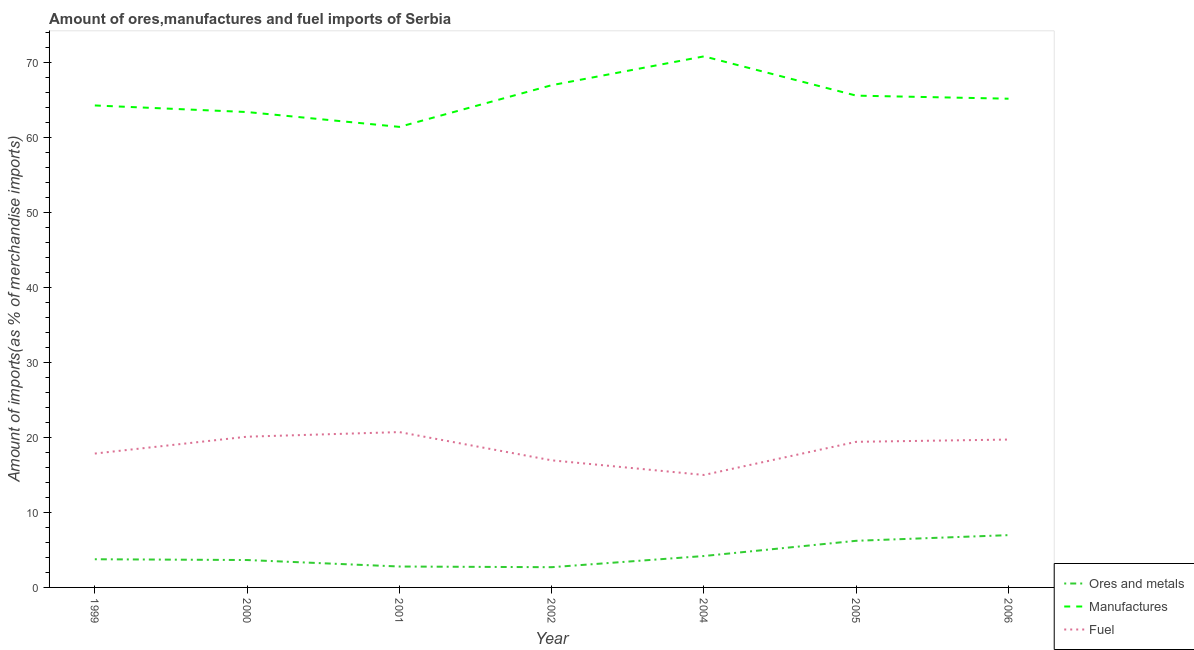What is the percentage of fuel imports in 2002?
Provide a succinct answer. 16.93. Across all years, what is the maximum percentage of ores and metals imports?
Your answer should be very brief. 6.97. Across all years, what is the minimum percentage of fuel imports?
Keep it short and to the point. 14.98. What is the total percentage of fuel imports in the graph?
Your response must be concise. 129.63. What is the difference between the percentage of ores and metals imports in 2002 and that in 2005?
Your answer should be very brief. -3.52. What is the difference between the percentage of manufactures imports in 2005 and the percentage of ores and metals imports in 2000?
Offer a very short reply. 61.87. What is the average percentage of manufactures imports per year?
Provide a short and direct response. 65.32. In the year 2000, what is the difference between the percentage of manufactures imports and percentage of ores and metals imports?
Keep it short and to the point. 59.69. In how many years, is the percentage of manufactures imports greater than 48 %?
Your response must be concise. 7. What is the ratio of the percentage of manufactures imports in 2000 to that in 2001?
Make the answer very short. 1.03. What is the difference between the highest and the second highest percentage of ores and metals imports?
Make the answer very short. 0.75. What is the difference between the highest and the lowest percentage of fuel imports?
Offer a terse response. 5.71. Is it the case that in every year, the sum of the percentage of ores and metals imports and percentage of manufactures imports is greater than the percentage of fuel imports?
Your response must be concise. Yes. Is the percentage of fuel imports strictly greater than the percentage of manufactures imports over the years?
Offer a terse response. No. Is the percentage of fuel imports strictly less than the percentage of ores and metals imports over the years?
Offer a very short reply. No. What is the difference between two consecutive major ticks on the Y-axis?
Your answer should be compact. 10. Does the graph contain any zero values?
Ensure brevity in your answer.  No. Does the graph contain grids?
Offer a terse response. No. Where does the legend appear in the graph?
Your answer should be very brief. Bottom right. How many legend labels are there?
Your answer should be very brief. 3. What is the title of the graph?
Make the answer very short. Amount of ores,manufactures and fuel imports of Serbia. What is the label or title of the Y-axis?
Your answer should be compact. Amount of imports(as % of merchandise imports). What is the Amount of imports(as % of merchandise imports) of Ores and metals in 1999?
Ensure brevity in your answer.  3.75. What is the Amount of imports(as % of merchandise imports) of Manufactures in 1999?
Your answer should be very brief. 64.21. What is the Amount of imports(as % of merchandise imports) of Fuel in 1999?
Give a very brief answer. 17.84. What is the Amount of imports(as % of merchandise imports) of Ores and metals in 2000?
Keep it short and to the point. 3.65. What is the Amount of imports(as % of merchandise imports) of Manufactures in 2000?
Your response must be concise. 63.34. What is the Amount of imports(as % of merchandise imports) in Fuel in 2000?
Your response must be concise. 20.08. What is the Amount of imports(as % of merchandise imports) in Ores and metals in 2001?
Your response must be concise. 2.79. What is the Amount of imports(as % of merchandise imports) in Manufactures in 2001?
Your response must be concise. 61.36. What is the Amount of imports(as % of merchandise imports) of Fuel in 2001?
Give a very brief answer. 20.7. What is the Amount of imports(as % of merchandise imports) in Ores and metals in 2002?
Your answer should be very brief. 2.7. What is the Amount of imports(as % of merchandise imports) of Manufactures in 2002?
Give a very brief answer. 66.91. What is the Amount of imports(as % of merchandise imports) in Fuel in 2002?
Offer a terse response. 16.93. What is the Amount of imports(as % of merchandise imports) of Ores and metals in 2004?
Offer a terse response. 4.18. What is the Amount of imports(as % of merchandise imports) in Manufactures in 2004?
Give a very brief answer. 70.75. What is the Amount of imports(as % of merchandise imports) of Fuel in 2004?
Your answer should be very brief. 14.98. What is the Amount of imports(as % of merchandise imports) of Ores and metals in 2005?
Give a very brief answer. 6.21. What is the Amount of imports(as % of merchandise imports) of Manufactures in 2005?
Make the answer very short. 65.52. What is the Amount of imports(as % of merchandise imports) in Fuel in 2005?
Your answer should be compact. 19.4. What is the Amount of imports(as % of merchandise imports) in Ores and metals in 2006?
Give a very brief answer. 6.97. What is the Amount of imports(as % of merchandise imports) of Manufactures in 2006?
Make the answer very short. 65.11. What is the Amount of imports(as % of merchandise imports) of Fuel in 2006?
Your answer should be compact. 19.7. Across all years, what is the maximum Amount of imports(as % of merchandise imports) of Ores and metals?
Offer a terse response. 6.97. Across all years, what is the maximum Amount of imports(as % of merchandise imports) of Manufactures?
Give a very brief answer. 70.75. Across all years, what is the maximum Amount of imports(as % of merchandise imports) in Fuel?
Give a very brief answer. 20.7. Across all years, what is the minimum Amount of imports(as % of merchandise imports) of Ores and metals?
Give a very brief answer. 2.7. Across all years, what is the minimum Amount of imports(as % of merchandise imports) of Manufactures?
Provide a short and direct response. 61.36. Across all years, what is the minimum Amount of imports(as % of merchandise imports) in Fuel?
Your response must be concise. 14.98. What is the total Amount of imports(as % of merchandise imports) of Ores and metals in the graph?
Make the answer very short. 30.25. What is the total Amount of imports(as % of merchandise imports) in Manufactures in the graph?
Provide a short and direct response. 457.21. What is the total Amount of imports(as % of merchandise imports) in Fuel in the graph?
Keep it short and to the point. 129.63. What is the difference between the Amount of imports(as % of merchandise imports) in Ores and metals in 1999 and that in 2000?
Your answer should be very brief. 0.1. What is the difference between the Amount of imports(as % of merchandise imports) in Manufactures in 1999 and that in 2000?
Provide a short and direct response. 0.88. What is the difference between the Amount of imports(as % of merchandise imports) of Fuel in 1999 and that in 2000?
Provide a short and direct response. -2.25. What is the difference between the Amount of imports(as % of merchandise imports) in Ores and metals in 1999 and that in 2001?
Ensure brevity in your answer.  0.97. What is the difference between the Amount of imports(as % of merchandise imports) of Manufactures in 1999 and that in 2001?
Provide a short and direct response. 2.85. What is the difference between the Amount of imports(as % of merchandise imports) of Fuel in 1999 and that in 2001?
Give a very brief answer. -2.86. What is the difference between the Amount of imports(as % of merchandise imports) of Ores and metals in 1999 and that in 2002?
Keep it short and to the point. 1.06. What is the difference between the Amount of imports(as % of merchandise imports) in Manufactures in 1999 and that in 2002?
Your answer should be compact. -2.7. What is the difference between the Amount of imports(as % of merchandise imports) in Fuel in 1999 and that in 2002?
Offer a very short reply. 0.9. What is the difference between the Amount of imports(as % of merchandise imports) of Ores and metals in 1999 and that in 2004?
Your response must be concise. -0.43. What is the difference between the Amount of imports(as % of merchandise imports) in Manufactures in 1999 and that in 2004?
Make the answer very short. -6.54. What is the difference between the Amount of imports(as % of merchandise imports) in Fuel in 1999 and that in 2004?
Make the answer very short. 2.85. What is the difference between the Amount of imports(as % of merchandise imports) in Ores and metals in 1999 and that in 2005?
Your answer should be compact. -2.46. What is the difference between the Amount of imports(as % of merchandise imports) in Manufactures in 1999 and that in 2005?
Provide a succinct answer. -1.31. What is the difference between the Amount of imports(as % of merchandise imports) of Fuel in 1999 and that in 2005?
Provide a short and direct response. -1.56. What is the difference between the Amount of imports(as % of merchandise imports) in Ores and metals in 1999 and that in 2006?
Give a very brief answer. -3.21. What is the difference between the Amount of imports(as % of merchandise imports) of Manufactures in 1999 and that in 2006?
Ensure brevity in your answer.  -0.9. What is the difference between the Amount of imports(as % of merchandise imports) in Fuel in 1999 and that in 2006?
Your response must be concise. -1.86. What is the difference between the Amount of imports(as % of merchandise imports) of Ores and metals in 2000 and that in 2001?
Your answer should be compact. 0.86. What is the difference between the Amount of imports(as % of merchandise imports) of Manufactures in 2000 and that in 2001?
Offer a terse response. 1.98. What is the difference between the Amount of imports(as % of merchandise imports) of Fuel in 2000 and that in 2001?
Offer a terse response. -0.61. What is the difference between the Amount of imports(as % of merchandise imports) in Ores and metals in 2000 and that in 2002?
Provide a short and direct response. 0.95. What is the difference between the Amount of imports(as % of merchandise imports) of Manufactures in 2000 and that in 2002?
Your response must be concise. -3.58. What is the difference between the Amount of imports(as % of merchandise imports) in Fuel in 2000 and that in 2002?
Give a very brief answer. 3.15. What is the difference between the Amount of imports(as % of merchandise imports) in Ores and metals in 2000 and that in 2004?
Ensure brevity in your answer.  -0.53. What is the difference between the Amount of imports(as % of merchandise imports) of Manufactures in 2000 and that in 2004?
Keep it short and to the point. -7.42. What is the difference between the Amount of imports(as % of merchandise imports) of Fuel in 2000 and that in 2004?
Your response must be concise. 5.1. What is the difference between the Amount of imports(as % of merchandise imports) of Ores and metals in 2000 and that in 2005?
Your response must be concise. -2.56. What is the difference between the Amount of imports(as % of merchandise imports) in Manufactures in 2000 and that in 2005?
Your answer should be very brief. -2.19. What is the difference between the Amount of imports(as % of merchandise imports) of Fuel in 2000 and that in 2005?
Offer a terse response. 0.68. What is the difference between the Amount of imports(as % of merchandise imports) of Ores and metals in 2000 and that in 2006?
Your answer should be very brief. -3.32. What is the difference between the Amount of imports(as % of merchandise imports) of Manufactures in 2000 and that in 2006?
Provide a succinct answer. -1.78. What is the difference between the Amount of imports(as % of merchandise imports) of Fuel in 2000 and that in 2006?
Offer a terse response. 0.38. What is the difference between the Amount of imports(as % of merchandise imports) in Ores and metals in 2001 and that in 2002?
Your response must be concise. 0.09. What is the difference between the Amount of imports(as % of merchandise imports) of Manufactures in 2001 and that in 2002?
Your response must be concise. -5.55. What is the difference between the Amount of imports(as % of merchandise imports) in Fuel in 2001 and that in 2002?
Offer a terse response. 3.76. What is the difference between the Amount of imports(as % of merchandise imports) of Ores and metals in 2001 and that in 2004?
Provide a short and direct response. -1.4. What is the difference between the Amount of imports(as % of merchandise imports) in Manufactures in 2001 and that in 2004?
Keep it short and to the point. -9.4. What is the difference between the Amount of imports(as % of merchandise imports) of Fuel in 2001 and that in 2004?
Make the answer very short. 5.71. What is the difference between the Amount of imports(as % of merchandise imports) of Ores and metals in 2001 and that in 2005?
Your response must be concise. -3.43. What is the difference between the Amount of imports(as % of merchandise imports) of Manufactures in 2001 and that in 2005?
Your answer should be compact. -4.16. What is the difference between the Amount of imports(as % of merchandise imports) in Fuel in 2001 and that in 2005?
Your answer should be compact. 1.3. What is the difference between the Amount of imports(as % of merchandise imports) in Ores and metals in 2001 and that in 2006?
Give a very brief answer. -4.18. What is the difference between the Amount of imports(as % of merchandise imports) of Manufactures in 2001 and that in 2006?
Your response must be concise. -3.75. What is the difference between the Amount of imports(as % of merchandise imports) in Fuel in 2001 and that in 2006?
Make the answer very short. 1. What is the difference between the Amount of imports(as % of merchandise imports) in Ores and metals in 2002 and that in 2004?
Your answer should be very brief. -1.49. What is the difference between the Amount of imports(as % of merchandise imports) in Manufactures in 2002 and that in 2004?
Your answer should be compact. -3.84. What is the difference between the Amount of imports(as % of merchandise imports) in Fuel in 2002 and that in 2004?
Ensure brevity in your answer.  1.95. What is the difference between the Amount of imports(as % of merchandise imports) in Ores and metals in 2002 and that in 2005?
Provide a short and direct response. -3.52. What is the difference between the Amount of imports(as % of merchandise imports) in Manufactures in 2002 and that in 2005?
Offer a very short reply. 1.39. What is the difference between the Amount of imports(as % of merchandise imports) of Fuel in 2002 and that in 2005?
Offer a terse response. -2.47. What is the difference between the Amount of imports(as % of merchandise imports) in Ores and metals in 2002 and that in 2006?
Your response must be concise. -4.27. What is the difference between the Amount of imports(as % of merchandise imports) in Manufactures in 2002 and that in 2006?
Give a very brief answer. 1.8. What is the difference between the Amount of imports(as % of merchandise imports) of Fuel in 2002 and that in 2006?
Provide a short and direct response. -2.77. What is the difference between the Amount of imports(as % of merchandise imports) of Ores and metals in 2004 and that in 2005?
Provide a succinct answer. -2.03. What is the difference between the Amount of imports(as % of merchandise imports) of Manufactures in 2004 and that in 2005?
Give a very brief answer. 5.23. What is the difference between the Amount of imports(as % of merchandise imports) of Fuel in 2004 and that in 2005?
Ensure brevity in your answer.  -4.42. What is the difference between the Amount of imports(as % of merchandise imports) of Ores and metals in 2004 and that in 2006?
Your answer should be compact. -2.78. What is the difference between the Amount of imports(as % of merchandise imports) of Manufactures in 2004 and that in 2006?
Provide a short and direct response. 5.64. What is the difference between the Amount of imports(as % of merchandise imports) in Fuel in 2004 and that in 2006?
Keep it short and to the point. -4.72. What is the difference between the Amount of imports(as % of merchandise imports) in Ores and metals in 2005 and that in 2006?
Your answer should be very brief. -0.75. What is the difference between the Amount of imports(as % of merchandise imports) in Manufactures in 2005 and that in 2006?
Make the answer very short. 0.41. What is the difference between the Amount of imports(as % of merchandise imports) of Fuel in 2005 and that in 2006?
Give a very brief answer. -0.3. What is the difference between the Amount of imports(as % of merchandise imports) of Ores and metals in 1999 and the Amount of imports(as % of merchandise imports) of Manufactures in 2000?
Your answer should be compact. -59.58. What is the difference between the Amount of imports(as % of merchandise imports) of Ores and metals in 1999 and the Amount of imports(as % of merchandise imports) of Fuel in 2000?
Ensure brevity in your answer.  -16.33. What is the difference between the Amount of imports(as % of merchandise imports) in Manufactures in 1999 and the Amount of imports(as % of merchandise imports) in Fuel in 2000?
Your response must be concise. 44.13. What is the difference between the Amount of imports(as % of merchandise imports) of Ores and metals in 1999 and the Amount of imports(as % of merchandise imports) of Manufactures in 2001?
Offer a very short reply. -57.6. What is the difference between the Amount of imports(as % of merchandise imports) in Ores and metals in 1999 and the Amount of imports(as % of merchandise imports) in Fuel in 2001?
Give a very brief answer. -16.94. What is the difference between the Amount of imports(as % of merchandise imports) in Manufactures in 1999 and the Amount of imports(as % of merchandise imports) in Fuel in 2001?
Make the answer very short. 43.52. What is the difference between the Amount of imports(as % of merchandise imports) of Ores and metals in 1999 and the Amount of imports(as % of merchandise imports) of Manufactures in 2002?
Make the answer very short. -63.16. What is the difference between the Amount of imports(as % of merchandise imports) of Ores and metals in 1999 and the Amount of imports(as % of merchandise imports) of Fuel in 2002?
Your answer should be compact. -13.18. What is the difference between the Amount of imports(as % of merchandise imports) of Manufactures in 1999 and the Amount of imports(as % of merchandise imports) of Fuel in 2002?
Make the answer very short. 47.28. What is the difference between the Amount of imports(as % of merchandise imports) of Ores and metals in 1999 and the Amount of imports(as % of merchandise imports) of Manufactures in 2004?
Ensure brevity in your answer.  -67. What is the difference between the Amount of imports(as % of merchandise imports) in Ores and metals in 1999 and the Amount of imports(as % of merchandise imports) in Fuel in 2004?
Your response must be concise. -11.23. What is the difference between the Amount of imports(as % of merchandise imports) of Manufactures in 1999 and the Amount of imports(as % of merchandise imports) of Fuel in 2004?
Provide a short and direct response. 49.23. What is the difference between the Amount of imports(as % of merchandise imports) in Ores and metals in 1999 and the Amount of imports(as % of merchandise imports) in Manufactures in 2005?
Provide a succinct answer. -61.77. What is the difference between the Amount of imports(as % of merchandise imports) of Ores and metals in 1999 and the Amount of imports(as % of merchandise imports) of Fuel in 2005?
Ensure brevity in your answer.  -15.65. What is the difference between the Amount of imports(as % of merchandise imports) in Manufactures in 1999 and the Amount of imports(as % of merchandise imports) in Fuel in 2005?
Your response must be concise. 44.81. What is the difference between the Amount of imports(as % of merchandise imports) of Ores and metals in 1999 and the Amount of imports(as % of merchandise imports) of Manufactures in 2006?
Your response must be concise. -61.36. What is the difference between the Amount of imports(as % of merchandise imports) in Ores and metals in 1999 and the Amount of imports(as % of merchandise imports) in Fuel in 2006?
Provide a succinct answer. -15.95. What is the difference between the Amount of imports(as % of merchandise imports) of Manufactures in 1999 and the Amount of imports(as % of merchandise imports) of Fuel in 2006?
Your response must be concise. 44.51. What is the difference between the Amount of imports(as % of merchandise imports) of Ores and metals in 2000 and the Amount of imports(as % of merchandise imports) of Manufactures in 2001?
Provide a succinct answer. -57.71. What is the difference between the Amount of imports(as % of merchandise imports) in Ores and metals in 2000 and the Amount of imports(as % of merchandise imports) in Fuel in 2001?
Offer a very short reply. -17.05. What is the difference between the Amount of imports(as % of merchandise imports) in Manufactures in 2000 and the Amount of imports(as % of merchandise imports) in Fuel in 2001?
Your response must be concise. 42.64. What is the difference between the Amount of imports(as % of merchandise imports) in Ores and metals in 2000 and the Amount of imports(as % of merchandise imports) in Manufactures in 2002?
Give a very brief answer. -63.26. What is the difference between the Amount of imports(as % of merchandise imports) of Ores and metals in 2000 and the Amount of imports(as % of merchandise imports) of Fuel in 2002?
Your answer should be compact. -13.28. What is the difference between the Amount of imports(as % of merchandise imports) in Manufactures in 2000 and the Amount of imports(as % of merchandise imports) in Fuel in 2002?
Offer a terse response. 46.4. What is the difference between the Amount of imports(as % of merchandise imports) in Ores and metals in 2000 and the Amount of imports(as % of merchandise imports) in Manufactures in 2004?
Your answer should be compact. -67.1. What is the difference between the Amount of imports(as % of merchandise imports) in Ores and metals in 2000 and the Amount of imports(as % of merchandise imports) in Fuel in 2004?
Offer a terse response. -11.33. What is the difference between the Amount of imports(as % of merchandise imports) in Manufactures in 2000 and the Amount of imports(as % of merchandise imports) in Fuel in 2004?
Give a very brief answer. 48.35. What is the difference between the Amount of imports(as % of merchandise imports) of Ores and metals in 2000 and the Amount of imports(as % of merchandise imports) of Manufactures in 2005?
Offer a very short reply. -61.87. What is the difference between the Amount of imports(as % of merchandise imports) in Ores and metals in 2000 and the Amount of imports(as % of merchandise imports) in Fuel in 2005?
Your answer should be compact. -15.75. What is the difference between the Amount of imports(as % of merchandise imports) of Manufactures in 2000 and the Amount of imports(as % of merchandise imports) of Fuel in 2005?
Give a very brief answer. 43.94. What is the difference between the Amount of imports(as % of merchandise imports) in Ores and metals in 2000 and the Amount of imports(as % of merchandise imports) in Manufactures in 2006?
Offer a terse response. -61.46. What is the difference between the Amount of imports(as % of merchandise imports) in Ores and metals in 2000 and the Amount of imports(as % of merchandise imports) in Fuel in 2006?
Make the answer very short. -16.05. What is the difference between the Amount of imports(as % of merchandise imports) of Manufactures in 2000 and the Amount of imports(as % of merchandise imports) of Fuel in 2006?
Keep it short and to the point. 43.64. What is the difference between the Amount of imports(as % of merchandise imports) of Ores and metals in 2001 and the Amount of imports(as % of merchandise imports) of Manufactures in 2002?
Your response must be concise. -64.13. What is the difference between the Amount of imports(as % of merchandise imports) of Ores and metals in 2001 and the Amount of imports(as % of merchandise imports) of Fuel in 2002?
Keep it short and to the point. -14.15. What is the difference between the Amount of imports(as % of merchandise imports) in Manufactures in 2001 and the Amount of imports(as % of merchandise imports) in Fuel in 2002?
Your answer should be compact. 44.42. What is the difference between the Amount of imports(as % of merchandise imports) in Ores and metals in 2001 and the Amount of imports(as % of merchandise imports) in Manufactures in 2004?
Your answer should be compact. -67.97. What is the difference between the Amount of imports(as % of merchandise imports) in Ores and metals in 2001 and the Amount of imports(as % of merchandise imports) in Fuel in 2004?
Make the answer very short. -12.2. What is the difference between the Amount of imports(as % of merchandise imports) in Manufactures in 2001 and the Amount of imports(as % of merchandise imports) in Fuel in 2004?
Your response must be concise. 46.37. What is the difference between the Amount of imports(as % of merchandise imports) of Ores and metals in 2001 and the Amount of imports(as % of merchandise imports) of Manufactures in 2005?
Ensure brevity in your answer.  -62.74. What is the difference between the Amount of imports(as % of merchandise imports) in Ores and metals in 2001 and the Amount of imports(as % of merchandise imports) in Fuel in 2005?
Ensure brevity in your answer.  -16.61. What is the difference between the Amount of imports(as % of merchandise imports) of Manufactures in 2001 and the Amount of imports(as % of merchandise imports) of Fuel in 2005?
Provide a short and direct response. 41.96. What is the difference between the Amount of imports(as % of merchandise imports) of Ores and metals in 2001 and the Amount of imports(as % of merchandise imports) of Manufactures in 2006?
Your response must be concise. -62.33. What is the difference between the Amount of imports(as % of merchandise imports) in Ores and metals in 2001 and the Amount of imports(as % of merchandise imports) in Fuel in 2006?
Your answer should be very brief. -16.91. What is the difference between the Amount of imports(as % of merchandise imports) in Manufactures in 2001 and the Amount of imports(as % of merchandise imports) in Fuel in 2006?
Your response must be concise. 41.66. What is the difference between the Amount of imports(as % of merchandise imports) of Ores and metals in 2002 and the Amount of imports(as % of merchandise imports) of Manufactures in 2004?
Provide a succinct answer. -68.06. What is the difference between the Amount of imports(as % of merchandise imports) of Ores and metals in 2002 and the Amount of imports(as % of merchandise imports) of Fuel in 2004?
Offer a very short reply. -12.29. What is the difference between the Amount of imports(as % of merchandise imports) of Manufactures in 2002 and the Amount of imports(as % of merchandise imports) of Fuel in 2004?
Provide a short and direct response. 51.93. What is the difference between the Amount of imports(as % of merchandise imports) in Ores and metals in 2002 and the Amount of imports(as % of merchandise imports) in Manufactures in 2005?
Your answer should be very brief. -62.83. What is the difference between the Amount of imports(as % of merchandise imports) of Ores and metals in 2002 and the Amount of imports(as % of merchandise imports) of Fuel in 2005?
Provide a short and direct response. -16.7. What is the difference between the Amount of imports(as % of merchandise imports) of Manufactures in 2002 and the Amount of imports(as % of merchandise imports) of Fuel in 2005?
Ensure brevity in your answer.  47.51. What is the difference between the Amount of imports(as % of merchandise imports) of Ores and metals in 2002 and the Amount of imports(as % of merchandise imports) of Manufactures in 2006?
Give a very brief answer. -62.42. What is the difference between the Amount of imports(as % of merchandise imports) of Ores and metals in 2002 and the Amount of imports(as % of merchandise imports) of Fuel in 2006?
Your response must be concise. -17. What is the difference between the Amount of imports(as % of merchandise imports) of Manufactures in 2002 and the Amount of imports(as % of merchandise imports) of Fuel in 2006?
Offer a terse response. 47.21. What is the difference between the Amount of imports(as % of merchandise imports) of Ores and metals in 2004 and the Amount of imports(as % of merchandise imports) of Manufactures in 2005?
Offer a very short reply. -61.34. What is the difference between the Amount of imports(as % of merchandise imports) of Ores and metals in 2004 and the Amount of imports(as % of merchandise imports) of Fuel in 2005?
Provide a succinct answer. -15.22. What is the difference between the Amount of imports(as % of merchandise imports) of Manufactures in 2004 and the Amount of imports(as % of merchandise imports) of Fuel in 2005?
Provide a succinct answer. 51.35. What is the difference between the Amount of imports(as % of merchandise imports) of Ores and metals in 2004 and the Amount of imports(as % of merchandise imports) of Manufactures in 2006?
Your answer should be compact. -60.93. What is the difference between the Amount of imports(as % of merchandise imports) in Ores and metals in 2004 and the Amount of imports(as % of merchandise imports) in Fuel in 2006?
Your answer should be compact. -15.52. What is the difference between the Amount of imports(as % of merchandise imports) of Manufactures in 2004 and the Amount of imports(as % of merchandise imports) of Fuel in 2006?
Offer a very short reply. 51.05. What is the difference between the Amount of imports(as % of merchandise imports) of Ores and metals in 2005 and the Amount of imports(as % of merchandise imports) of Manufactures in 2006?
Your answer should be compact. -58.9. What is the difference between the Amount of imports(as % of merchandise imports) in Ores and metals in 2005 and the Amount of imports(as % of merchandise imports) in Fuel in 2006?
Ensure brevity in your answer.  -13.49. What is the difference between the Amount of imports(as % of merchandise imports) in Manufactures in 2005 and the Amount of imports(as % of merchandise imports) in Fuel in 2006?
Offer a terse response. 45.82. What is the average Amount of imports(as % of merchandise imports) of Ores and metals per year?
Ensure brevity in your answer.  4.32. What is the average Amount of imports(as % of merchandise imports) in Manufactures per year?
Provide a succinct answer. 65.32. What is the average Amount of imports(as % of merchandise imports) in Fuel per year?
Provide a short and direct response. 18.52. In the year 1999, what is the difference between the Amount of imports(as % of merchandise imports) of Ores and metals and Amount of imports(as % of merchandise imports) of Manufactures?
Offer a terse response. -60.46. In the year 1999, what is the difference between the Amount of imports(as % of merchandise imports) in Ores and metals and Amount of imports(as % of merchandise imports) in Fuel?
Your answer should be compact. -14.08. In the year 1999, what is the difference between the Amount of imports(as % of merchandise imports) of Manufactures and Amount of imports(as % of merchandise imports) of Fuel?
Your answer should be compact. 46.38. In the year 2000, what is the difference between the Amount of imports(as % of merchandise imports) of Ores and metals and Amount of imports(as % of merchandise imports) of Manufactures?
Your answer should be very brief. -59.69. In the year 2000, what is the difference between the Amount of imports(as % of merchandise imports) in Ores and metals and Amount of imports(as % of merchandise imports) in Fuel?
Offer a terse response. -16.43. In the year 2000, what is the difference between the Amount of imports(as % of merchandise imports) of Manufactures and Amount of imports(as % of merchandise imports) of Fuel?
Provide a short and direct response. 43.25. In the year 2001, what is the difference between the Amount of imports(as % of merchandise imports) in Ores and metals and Amount of imports(as % of merchandise imports) in Manufactures?
Your answer should be very brief. -58.57. In the year 2001, what is the difference between the Amount of imports(as % of merchandise imports) of Ores and metals and Amount of imports(as % of merchandise imports) of Fuel?
Offer a terse response. -17.91. In the year 2001, what is the difference between the Amount of imports(as % of merchandise imports) in Manufactures and Amount of imports(as % of merchandise imports) in Fuel?
Your answer should be very brief. 40.66. In the year 2002, what is the difference between the Amount of imports(as % of merchandise imports) in Ores and metals and Amount of imports(as % of merchandise imports) in Manufactures?
Offer a terse response. -64.22. In the year 2002, what is the difference between the Amount of imports(as % of merchandise imports) of Ores and metals and Amount of imports(as % of merchandise imports) of Fuel?
Offer a terse response. -14.24. In the year 2002, what is the difference between the Amount of imports(as % of merchandise imports) in Manufactures and Amount of imports(as % of merchandise imports) in Fuel?
Offer a very short reply. 49.98. In the year 2004, what is the difference between the Amount of imports(as % of merchandise imports) in Ores and metals and Amount of imports(as % of merchandise imports) in Manufactures?
Offer a terse response. -66.57. In the year 2004, what is the difference between the Amount of imports(as % of merchandise imports) in Ores and metals and Amount of imports(as % of merchandise imports) in Fuel?
Your response must be concise. -10.8. In the year 2004, what is the difference between the Amount of imports(as % of merchandise imports) in Manufactures and Amount of imports(as % of merchandise imports) in Fuel?
Make the answer very short. 55.77. In the year 2005, what is the difference between the Amount of imports(as % of merchandise imports) in Ores and metals and Amount of imports(as % of merchandise imports) in Manufactures?
Provide a short and direct response. -59.31. In the year 2005, what is the difference between the Amount of imports(as % of merchandise imports) of Ores and metals and Amount of imports(as % of merchandise imports) of Fuel?
Your answer should be very brief. -13.19. In the year 2005, what is the difference between the Amount of imports(as % of merchandise imports) of Manufactures and Amount of imports(as % of merchandise imports) of Fuel?
Your answer should be very brief. 46.12. In the year 2006, what is the difference between the Amount of imports(as % of merchandise imports) in Ores and metals and Amount of imports(as % of merchandise imports) in Manufactures?
Offer a very short reply. -58.15. In the year 2006, what is the difference between the Amount of imports(as % of merchandise imports) of Ores and metals and Amount of imports(as % of merchandise imports) of Fuel?
Your answer should be compact. -12.73. In the year 2006, what is the difference between the Amount of imports(as % of merchandise imports) in Manufactures and Amount of imports(as % of merchandise imports) in Fuel?
Provide a succinct answer. 45.41. What is the ratio of the Amount of imports(as % of merchandise imports) in Ores and metals in 1999 to that in 2000?
Offer a terse response. 1.03. What is the ratio of the Amount of imports(as % of merchandise imports) in Manufactures in 1999 to that in 2000?
Provide a succinct answer. 1.01. What is the ratio of the Amount of imports(as % of merchandise imports) in Fuel in 1999 to that in 2000?
Provide a succinct answer. 0.89. What is the ratio of the Amount of imports(as % of merchandise imports) in Ores and metals in 1999 to that in 2001?
Offer a very short reply. 1.35. What is the ratio of the Amount of imports(as % of merchandise imports) of Manufactures in 1999 to that in 2001?
Provide a short and direct response. 1.05. What is the ratio of the Amount of imports(as % of merchandise imports) in Fuel in 1999 to that in 2001?
Provide a succinct answer. 0.86. What is the ratio of the Amount of imports(as % of merchandise imports) of Ores and metals in 1999 to that in 2002?
Keep it short and to the point. 1.39. What is the ratio of the Amount of imports(as % of merchandise imports) in Manufactures in 1999 to that in 2002?
Your answer should be compact. 0.96. What is the ratio of the Amount of imports(as % of merchandise imports) in Fuel in 1999 to that in 2002?
Your response must be concise. 1.05. What is the ratio of the Amount of imports(as % of merchandise imports) of Ores and metals in 1999 to that in 2004?
Give a very brief answer. 0.9. What is the ratio of the Amount of imports(as % of merchandise imports) in Manufactures in 1999 to that in 2004?
Provide a succinct answer. 0.91. What is the ratio of the Amount of imports(as % of merchandise imports) of Fuel in 1999 to that in 2004?
Keep it short and to the point. 1.19. What is the ratio of the Amount of imports(as % of merchandise imports) of Ores and metals in 1999 to that in 2005?
Ensure brevity in your answer.  0.6. What is the ratio of the Amount of imports(as % of merchandise imports) in Manufactures in 1999 to that in 2005?
Provide a succinct answer. 0.98. What is the ratio of the Amount of imports(as % of merchandise imports) of Fuel in 1999 to that in 2005?
Offer a very short reply. 0.92. What is the ratio of the Amount of imports(as % of merchandise imports) of Ores and metals in 1999 to that in 2006?
Ensure brevity in your answer.  0.54. What is the ratio of the Amount of imports(as % of merchandise imports) of Manufactures in 1999 to that in 2006?
Keep it short and to the point. 0.99. What is the ratio of the Amount of imports(as % of merchandise imports) of Fuel in 1999 to that in 2006?
Provide a succinct answer. 0.91. What is the ratio of the Amount of imports(as % of merchandise imports) in Ores and metals in 2000 to that in 2001?
Offer a terse response. 1.31. What is the ratio of the Amount of imports(as % of merchandise imports) of Manufactures in 2000 to that in 2001?
Make the answer very short. 1.03. What is the ratio of the Amount of imports(as % of merchandise imports) in Fuel in 2000 to that in 2001?
Provide a succinct answer. 0.97. What is the ratio of the Amount of imports(as % of merchandise imports) of Ores and metals in 2000 to that in 2002?
Your answer should be compact. 1.35. What is the ratio of the Amount of imports(as % of merchandise imports) in Manufactures in 2000 to that in 2002?
Offer a very short reply. 0.95. What is the ratio of the Amount of imports(as % of merchandise imports) in Fuel in 2000 to that in 2002?
Make the answer very short. 1.19. What is the ratio of the Amount of imports(as % of merchandise imports) in Ores and metals in 2000 to that in 2004?
Give a very brief answer. 0.87. What is the ratio of the Amount of imports(as % of merchandise imports) of Manufactures in 2000 to that in 2004?
Offer a very short reply. 0.9. What is the ratio of the Amount of imports(as % of merchandise imports) of Fuel in 2000 to that in 2004?
Your answer should be very brief. 1.34. What is the ratio of the Amount of imports(as % of merchandise imports) in Ores and metals in 2000 to that in 2005?
Ensure brevity in your answer.  0.59. What is the ratio of the Amount of imports(as % of merchandise imports) in Manufactures in 2000 to that in 2005?
Make the answer very short. 0.97. What is the ratio of the Amount of imports(as % of merchandise imports) in Fuel in 2000 to that in 2005?
Your answer should be compact. 1.04. What is the ratio of the Amount of imports(as % of merchandise imports) in Ores and metals in 2000 to that in 2006?
Ensure brevity in your answer.  0.52. What is the ratio of the Amount of imports(as % of merchandise imports) in Manufactures in 2000 to that in 2006?
Provide a short and direct response. 0.97. What is the ratio of the Amount of imports(as % of merchandise imports) of Fuel in 2000 to that in 2006?
Your answer should be very brief. 1.02. What is the ratio of the Amount of imports(as % of merchandise imports) in Manufactures in 2001 to that in 2002?
Make the answer very short. 0.92. What is the ratio of the Amount of imports(as % of merchandise imports) of Fuel in 2001 to that in 2002?
Provide a succinct answer. 1.22. What is the ratio of the Amount of imports(as % of merchandise imports) in Ores and metals in 2001 to that in 2004?
Your answer should be compact. 0.67. What is the ratio of the Amount of imports(as % of merchandise imports) of Manufactures in 2001 to that in 2004?
Your answer should be very brief. 0.87. What is the ratio of the Amount of imports(as % of merchandise imports) in Fuel in 2001 to that in 2004?
Make the answer very short. 1.38. What is the ratio of the Amount of imports(as % of merchandise imports) in Ores and metals in 2001 to that in 2005?
Provide a succinct answer. 0.45. What is the ratio of the Amount of imports(as % of merchandise imports) of Manufactures in 2001 to that in 2005?
Your answer should be compact. 0.94. What is the ratio of the Amount of imports(as % of merchandise imports) in Fuel in 2001 to that in 2005?
Provide a short and direct response. 1.07. What is the ratio of the Amount of imports(as % of merchandise imports) in Ores and metals in 2001 to that in 2006?
Your answer should be very brief. 0.4. What is the ratio of the Amount of imports(as % of merchandise imports) of Manufactures in 2001 to that in 2006?
Your answer should be very brief. 0.94. What is the ratio of the Amount of imports(as % of merchandise imports) in Fuel in 2001 to that in 2006?
Offer a very short reply. 1.05. What is the ratio of the Amount of imports(as % of merchandise imports) in Ores and metals in 2002 to that in 2004?
Your answer should be compact. 0.64. What is the ratio of the Amount of imports(as % of merchandise imports) in Manufactures in 2002 to that in 2004?
Your answer should be compact. 0.95. What is the ratio of the Amount of imports(as % of merchandise imports) of Fuel in 2002 to that in 2004?
Your answer should be very brief. 1.13. What is the ratio of the Amount of imports(as % of merchandise imports) in Ores and metals in 2002 to that in 2005?
Offer a very short reply. 0.43. What is the ratio of the Amount of imports(as % of merchandise imports) of Manufactures in 2002 to that in 2005?
Keep it short and to the point. 1.02. What is the ratio of the Amount of imports(as % of merchandise imports) in Fuel in 2002 to that in 2005?
Your answer should be compact. 0.87. What is the ratio of the Amount of imports(as % of merchandise imports) in Ores and metals in 2002 to that in 2006?
Offer a very short reply. 0.39. What is the ratio of the Amount of imports(as % of merchandise imports) in Manufactures in 2002 to that in 2006?
Your answer should be very brief. 1.03. What is the ratio of the Amount of imports(as % of merchandise imports) of Fuel in 2002 to that in 2006?
Give a very brief answer. 0.86. What is the ratio of the Amount of imports(as % of merchandise imports) in Ores and metals in 2004 to that in 2005?
Offer a terse response. 0.67. What is the ratio of the Amount of imports(as % of merchandise imports) in Manufactures in 2004 to that in 2005?
Your answer should be compact. 1.08. What is the ratio of the Amount of imports(as % of merchandise imports) in Fuel in 2004 to that in 2005?
Your response must be concise. 0.77. What is the ratio of the Amount of imports(as % of merchandise imports) of Ores and metals in 2004 to that in 2006?
Your answer should be compact. 0.6. What is the ratio of the Amount of imports(as % of merchandise imports) of Manufactures in 2004 to that in 2006?
Keep it short and to the point. 1.09. What is the ratio of the Amount of imports(as % of merchandise imports) in Fuel in 2004 to that in 2006?
Your answer should be very brief. 0.76. What is the ratio of the Amount of imports(as % of merchandise imports) of Ores and metals in 2005 to that in 2006?
Provide a succinct answer. 0.89. What is the ratio of the Amount of imports(as % of merchandise imports) of Manufactures in 2005 to that in 2006?
Provide a succinct answer. 1.01. What is the ratio of the Amount of imports(as % of merchandise imports) in Fuel in 2005 to that in 2006?
Keep it short and to the point. 0.98. What is the difference between the highest and the second highest Amount of imports(as % of merchandise imports) in Ores and metals?
Make the answer very short. 0.75. What is the difference between the highest and the second highest Amount of imports(as % of merchandise imports) of Manufactures?
Your answer should be compact. 3.84. What is the difference between the highest and the second highest Amount of imports(as % of merchandise imports) in Fuel?
Your answer should be very brief. 0.61. What is the difference between the highest and the lowest Amount of imports(as % of merchandise imports) in Ores and metals?
Provide a short and direct response. 4.27. What is the difference between the highest and the lowest Amount of imports(as % of merchandise imports) in Manufactures?
Provide a short and direct response. 9.4. What is the difference between the highest and the lowest Amount of imports(as % of merchandise imports) of Fuel?
Provide a succinct answer. 5.71. 